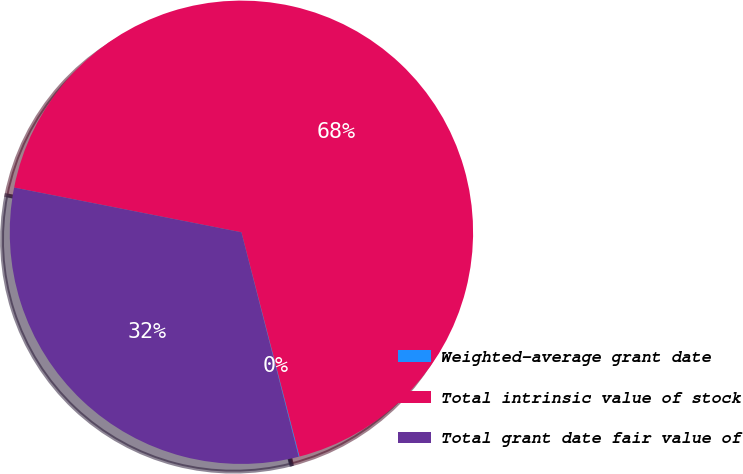Convert chart to OTSL. <chart><loc_0><loc_0><loc_500><loc_500><pie_chart><fcel>Weighted-average grant date<fcel>Total intrinsic value of stock<fcel>Total grant date fair value of<nl><fcel>0.06%<fcel>67.87%<fcel>32.07%<nl></chart> 